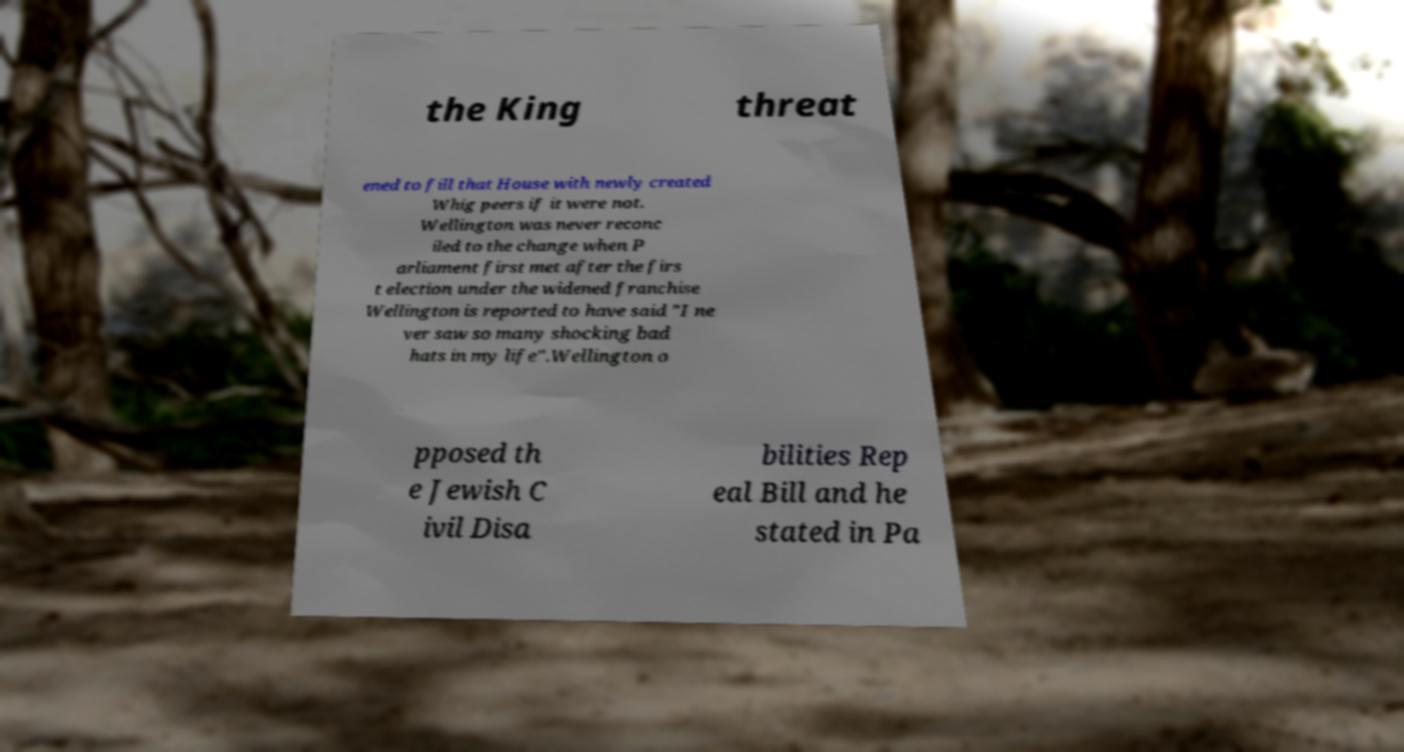Please identify and transcribe the text found in this image. the King threat ened to fill that House with newly created Whig peers if it were not. Wellington was never reconc iled to the change when P arliament first met after the firs t election under the widened franchise Wellington is reported to have said "I ne ver saw so many shocking bad hats in my life".Wellington o pposed th e Jewish C ivil Disa bilities Rep eal Bill and he stated in Pa 